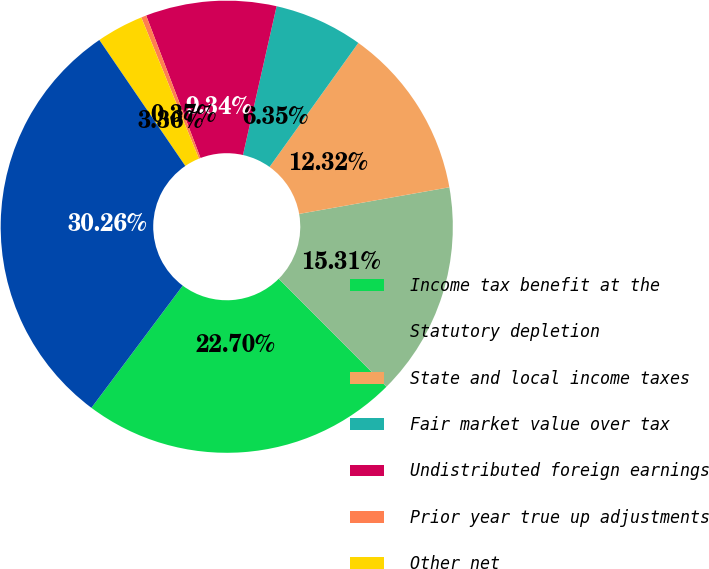Convert chart. <chart><loc_0><loc_0><loc_500><loc_500><pie_chart><fcel>Income tax benefit at the<fcel>Statutory depletion<fcel>State and local income taxes<fcel>Fair market value over tax<fcel>Undistributed foreign earnings<fcel>Prior year true up adjustments<fcel>Other net<fcel>Total income tax benefit<nl><fcel>22.7%<fcel>15.31%<fcel>12.32%<fcel>6.35%<fcel>9.34%<fcel>0.37%<fcel>3.36%<fcel>30.26%<nl></chart> 